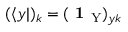<formula> <loc_0><loc_0><loc_500><loc_500>( \langle y | ) _ { k } = ( 1 _ { Y } ) _ { y k }</formula> 